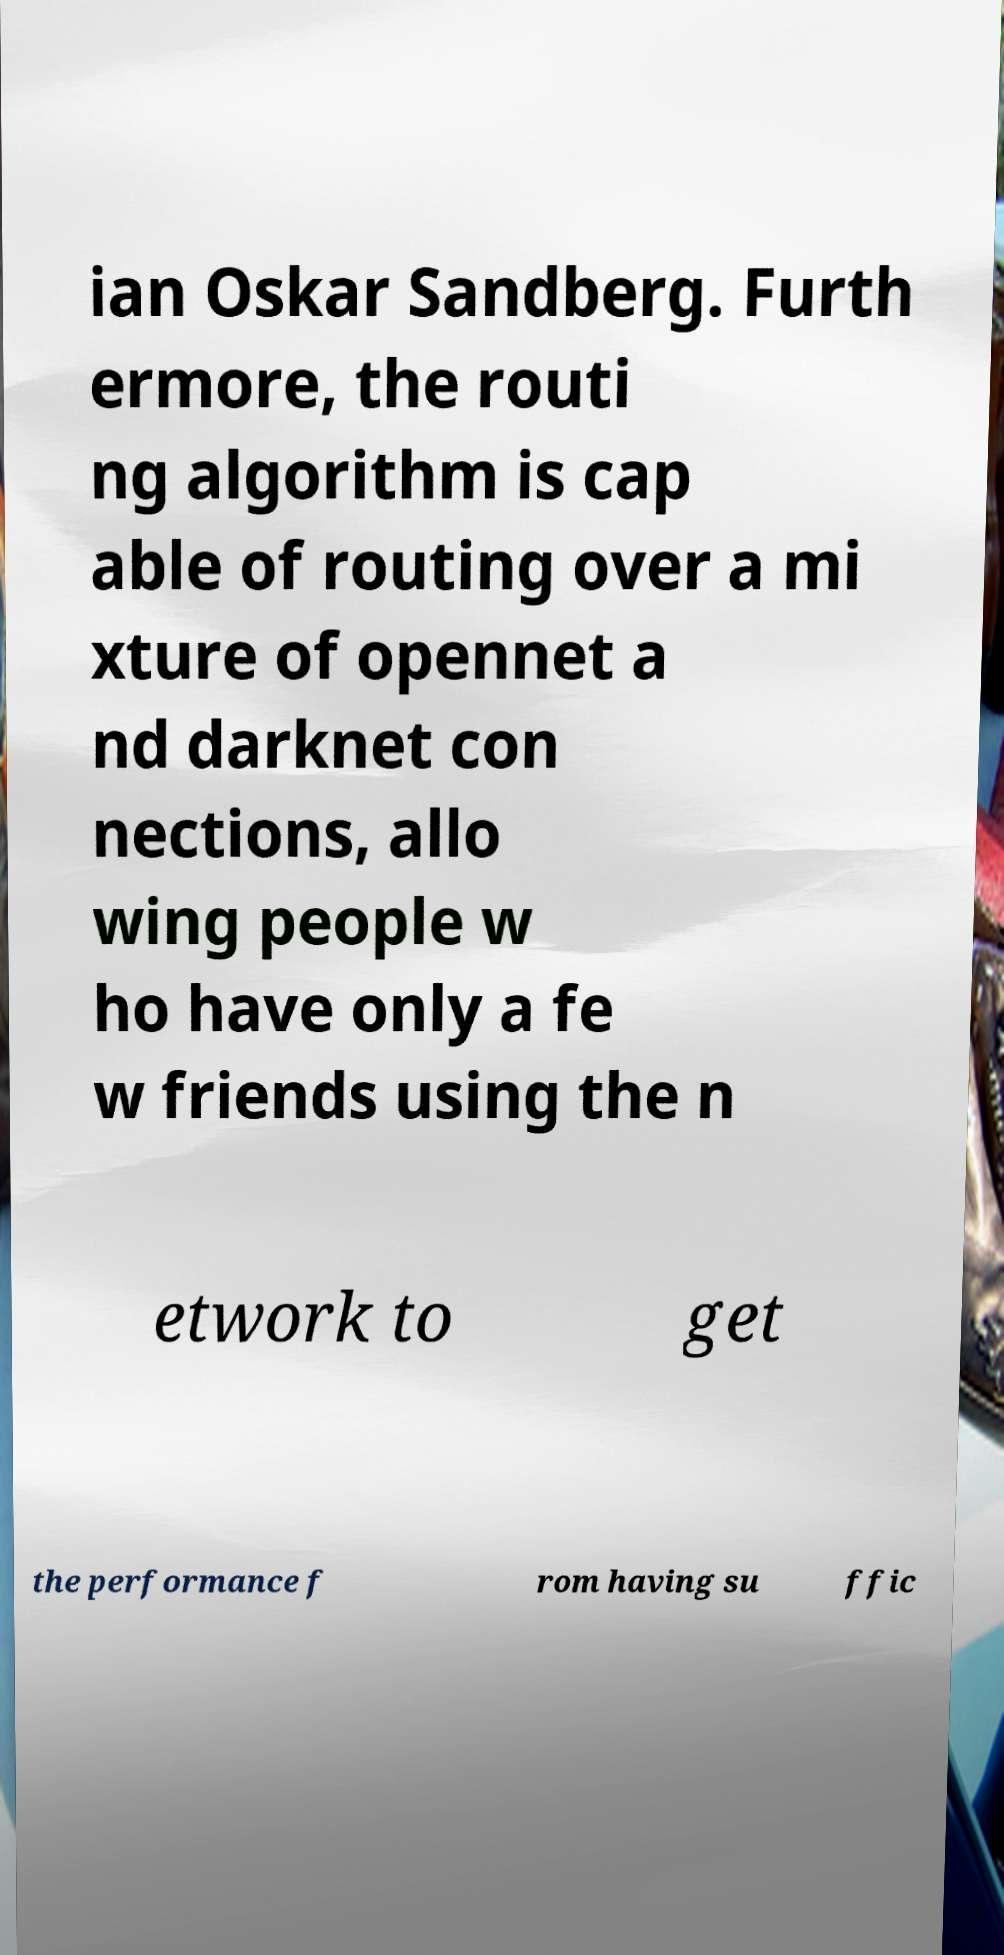Please read and relay the text visible in this image. What does it say? ian Oskar Sandberg. Furth ermore, the routi ng algorithm is cap able of routing over a mi xture of opennet a nd darknet con nections, allo wing people w ho have only a fe w friends using the n etwork to get the performance f rom having su ffic 